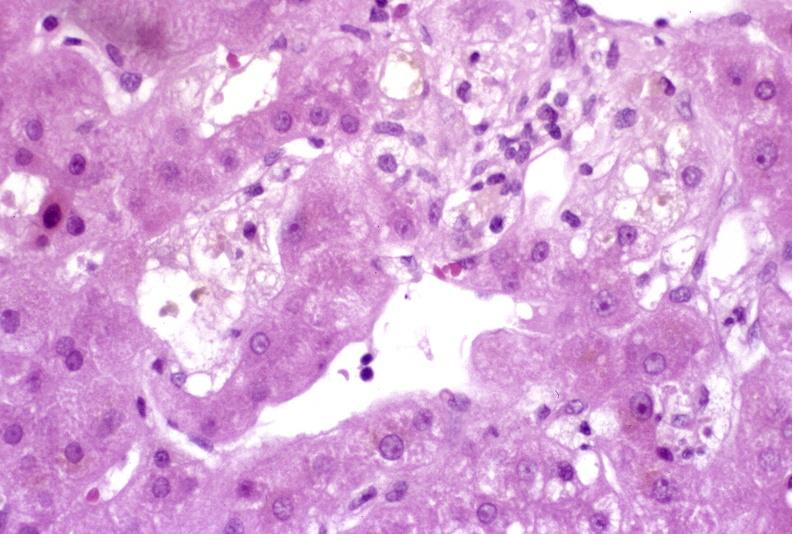does this image show recovery of ducts?
Answer the question using a single word or phrase. Yes 